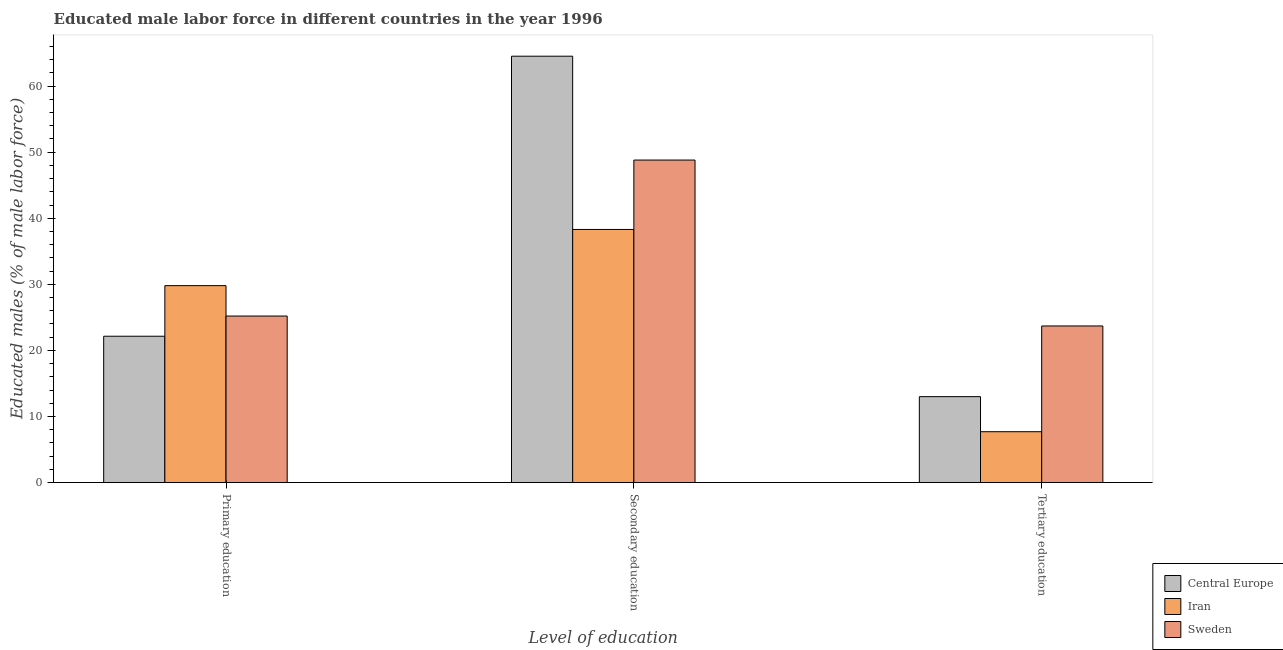Are the number of bars per tick equal to the number of legend labels?
Your answer should be compact. Yes. Are the number of bars on each tick of the X-axis equal?
Keep it short and to the point. Yes. How many bars are there on the 3rd tick from the left?
Offer a very short reply. 3. How many bars are there on the 2nd tick from the right?
Your answer should be compact. 3. What is the label of the 3rd group of bars from the left?
Make the answer very short. Tertiary education. What is the percentage of male labor force who received secondary education in Sweden?
Provide a succinct answer. 48.8. Across all countries, what is the maximum percentage of male labor force who received primary education?
Keep it short and to the point. 29.8. Across all countries, what is the minimum percentage of male labor force who received secondary education?
Give a very brief answer. 38.3. In which country was the percentage of male labor force who received primary education maximum?
Your response must be concise. Iran. In which country was the percentage of male labor force who received primary education minimum?
Your response must be concise. Central Europe. What is the total percentage of male labor force who received tertiary education in the graph?
Your answer should be very brief. 44.4. What is the difference between the percentage of male labor force who received primary education in Iran and that in Sweden?
Your response must be concise. 4.6. What is the difference between the percentage of male labor force who received secondary education in Central Europe and the percentage of male labor force who received primary education in Iran?
Keep it short and to the point. 34.71. What is the average percentage of male labor force who received tertiary education per country?
Provide a succinct answer. 14.8. What is the difference between the percentage of male labor force who received primary education and percentage of male labor force who received tertiary education in Sweden?
Your answer should be compact. 1.5. In how many countries, is the percentage of male labor force who received tertiary education greater than 58 %?
Make the answer very short. 0. What is the ratio of the percentage of male labor force who received tertiary education in Sweden to that in Iran?
Offer a terse response. 3.08. Is the difference between the percentage of male labor force who received secondary education in Iran and Central Europe greater than the difference between the percentage of male labor force who received tertiary education in Iran and Central Europe?
Give a very brief answer. No. What is the difference between the highest and the second highest percentage of male labor force who received secondary education?
Your answer should be compact. 15.71. What is the difference between the highest and the lowest percentage of male labor force who received primary education?
Make the answer very short. 7.65. In how many countries, is the percentage of male labor force who received secondary education greater than the average percentage of male labor force who received secondary education taken over all countries?
Ensure brevity in your answer.  1. Is the sum of the percentage of male labor force who received primary education in Iran and Sweden greater than the maximum percentage of male labor force who received secondary education across all countries?
Provide a succinct answer. No. What does the 3rd bar from the left in Primary education represents?
Offer a very short reply. Sweden. What does the 1st bar from the right in Tertiary education represents?
Give a very brief answer. Sweden. Is it the case that in every country, the sum of the percentage of male labor force who received primary education and percentage of male labor force who received secondary education is greater than the percentage of male labor force who received tertiary education?
Your answer should be compact. Yes. How many bars are there?
Provide a short and direct response. 9. Are all the bars in the graph horizontal?
Offer a very short reply. No. How many countries are there in the graph?
Provide a short and direct response. 3. Are the values on the major ticks of Y-axis written in scientific E-notation?
Give a very brief answer. No. Does the graph contain any zero values?
Make the answer very short. No. Does the graph contain grids?
Your answer should be very brief. No. Where does the legend appear in the graph?
Offer a terse response. Bottom right. What is the title of the graph?
Ensure brevity in your answer.  Educated male labor force in different countries in the year 1996. What is the label or title of the X-axis?
Give a very brief answer. Level of education. What is the label or title of the Y-axis?
Your answer should be very brief. Educated males (% of male labor force). What is the Educated males (% of male labor force) of Central Europe in Primary education?
Offer a terse response. 22.15. What is the Educated males (% of male labor force) in Iran in Primary education?
Give a very brief answer. 29.8. What is the Educated males (% of male labor force) in Sweden in Primary education?
Offer a very short reply. 25.2. What is the Educated males (% of male labor force) in Central Europe in Secondary education?
Keep it short and to the point. 64.51. What is the Educated males (% of male labor force) in Iran in Secondary education?
Offer a terse response. 38.3. What is the Educated males (% of male labor force) of Sweden in Secondary education?
Make the answer very short. 48.8. What is the Educated males (% of male labor force) of Central Europe in Tertiary education?
Your response must be concise. 13. What is the Educated males (% of male labor force) in Iran in Tertiary education?
Your answer should be very brief. 7.7. What is the Educated males (% of male labor force) of Sweden in Tertiary education?
Offer a terse response. 23.7. Across all Level of education, what is the maximum Educated males (% of male labor force) in Central Europe?
Give a very brief answer. 64.51. Across all Level of education, what is the maximum Educated males (% of male labor force) of Iran?
Offer a very short reply. 38.3. Across all Level of education, what is the maximum Educated males (% of male labor force) in Sweden?
Your response must be concise. 48.8. Across all Level of education, what is the minimum Educated males (% of male labor force) of Central Europe?
Provide a succinct answer. 13. Across all Level of education, what is the minimum Educated males (% of male labor force) of Iran?
Provide a short and direct response. 7.7. Across all Level of education, what is the minimum Educated males (% of male labor force) of Sweden?
Provide a short and direct response. 23.7. What is the total Educated males (% of male labor force) in Central Europe in the graph?
Offer a terse response. 99.67. What is the total Educated males (% of male labor force) in Iran in the graph?
Your answer should be very brief. 75.8. What is the total Educated males (% of male labor force) of Sweden in the graph?
Make the answer very short. 97.7. What is the difference between the Educated males (% of male labor force) in Central Europe in Primary education and that in Secondary education?
Provide a short and direct response. -42.37. What is the difference between the Educated males (% of male labor force) of Iran in Primary education and that in Secondary education?
Your answer should be compact. -8.5. What is the difference between the Educated males (% of male labor force) of Sweden in Primary education and that in Secondary education?
Make the answer very short. -23.6. What is the difference between the Educated males (% of male labor force) of Central Europe in Primary education and that in Tertiary education?
Make the answer very short. 9.14. What is the difference between the Educated males (% of male labor force) of Iran in Primary education and that in Tertiary education?
Your response must be concise. 22.1. What is the difference between the Educated males (% of male labor force) of Sweden in Primary education and that in Tertiary education?
Offer a very short reply. 1.5. What is the difference between the Educated males (% of male labor force) of Central Europe in Secondary education and that in Tertiary education?
Provide a succinct answer. 51.51. What is the difference between the Educated males (% of male labor force) of Iran in Secondary education and that in Tertiary education?
Give a very brief answer. 30.6. What is the difference between the Educated males (% of male labor force) in Sweden in Secondary education and that in Tertiary education?
Your answer should be very brief. 25.1. What is the difference between the Educated males (% of male labor force) in Central Europe in Primary education and the Educated males (% of male labor force) in Iran in Secondary education?
Offer a very short reply. -16.15. What is the difference between the Educated males (% of male labor force) in Central Europe in Primary education and the Educated males (% of male labor force) in Sweden in Secondary education?
Offer a very short reply. -26.65. What is the difference between the Educated males (% of male labor force) of Iran in Primary education and the Educated males (% of male labor force) of Sweden in Secondary education?
Ensure brevity in your answer.  -19. What is the difference between the Educated males (% of male labor force) in Central Europe in Primary education and the Educated males (% of male labor force) in Iran in Tertiary education?
Offer a terse response. 14.45. What is the difference between the Educated males (% of male labor force) of Central Europe in Primary education and the Educated males (% of male labor force) of Sweden in Tertiary education?
Your answer should be compact. -1.55. What is the difference between the Educated males (% of male labor force) in Central Europe in Secondary education and the Educated males (% of male labor force) in Iran in Tertiary education?
Keep it short and to the point. 56.81. What is the difference between the Educated males (% of male labor force) in Central Europe in Secondary education and the Educated males (% of male labor force) in Sweden in Tertiary education?
Provide a succinct answer. 40.81. What is the average Educated males (% of male labor force) of Central Europe per Level of education?
Your answer should be very brief. 33.22. What is the average Educated males (% of male labor force) of Iran per Level of education?
Ensure brevity in your answer.  25.27. What is the average Educated males (% of male labor force) of Sweden per Level of education?
Offer a very short reply. 32.57. What is the difference between the Educated males (% of male labor force) in Central Europe and Educated males (% of male labor force) in Iran in Primary education?
Ensure brevity in your answer.  -7.65. What is the difference between the Educated males (% of male labor force) in Central Europe and Educated males (% of male labor force) in Sweden in Primary education?
Provide a short and direct response. -3.05. What is the difference between the Educated males (% of male labor force) in Iran and Educated males (% of male labor force) in Sweden in Primary education?
Make the answer very short. 4.6. What is the difference between the Educated males (% of male labor force) in Central Europe and Educated males (% of male labor force) in Iran in Secondary education?
Your answer should be compact. 26.21. What is the difference between the Educated males (% of male labor force) of Central Europe and Educated males (% of male labor force) of Sweden in Secondary education?
Your answer should be compact. 15.71. What is the difference between the Educated males (% of male labor force) of Central Europe and Educated males (% of male labor force) of Iran in Tertiary education?
Provide a succinct answer. 5.3. What is the difference between the Educated males (% of male labor force) of Central Europe and Educated males (% of male labor force) of Sweden in Tertiary education?
Make the answer very short. -10.7. What is the ratio of the Educated males (% of male labor force) of Central Europe in Primary education to that in Secondary education?
Ensure brevity in your answer.  0.34. What is the ratio of the Educated males (% of male labor force) of Iran in Primary education to that in Secondary education?
Your response must be concise. 0.78. What is the ratio of the Educated males (% of male labor force) in Sweden in Primary education to that in Secondary education?
Provide a succinct answer. 0.52. What is the ratio of the Educated males (% of male labor force) of Central Europe in Primary education to that in Tertiary education?
Your answer should be compact. 1.7. What is the ratio of the Educated males (% of male labor force) of Iran in Primary education to that in Tertiary education?
Give a very brief answer. 3.87. What is the ratio of the Educated males (% of male labor force) of Sweden in Primary education to that in Tertiary education?
Offer a terse response. 1.06. What is the ratio of the Educated males (% of male labor force) in Central Europe in Secondary education to that in Tertiary education?
Your answer should be very brief. 4.96. What is the ratio of the Educated males (% of male labor force) of Iran in Secondary education to that in Tertiary education?
Provide a succinct answer. 4.97. What is the ratio of the Educated males (% of male labor force) in Sweden in Secondary education to that in Tertiary education?
Provide a short and direct response. 2.06. What is the difference between the highest and the second highest Educated males (% of male labor force) of Central Europe?
Your answer should be very brief. 42.37. What is the difference between the highest and the second highest Educated males (% of male labor force) of Iran?
Your answer should be compact. 8.5. What is the difference between the highest and the second highest Educated males (% of male labor force) in Sweden?
Your answer should be compact. 23.6. What is the difference between the highest and the lowest Educated males (% of male labor force) in Central Europe?
Make the answer very short. 51.51. What is the difference between the highest and the lowest Educated males (% of male labor force) in Iran?
Your answer should be very brief. 30.6. What is the difference between the highest and the lowest Educated males (% of male labor force) in Sweden?
Provide a short and direct response. 25.1. 